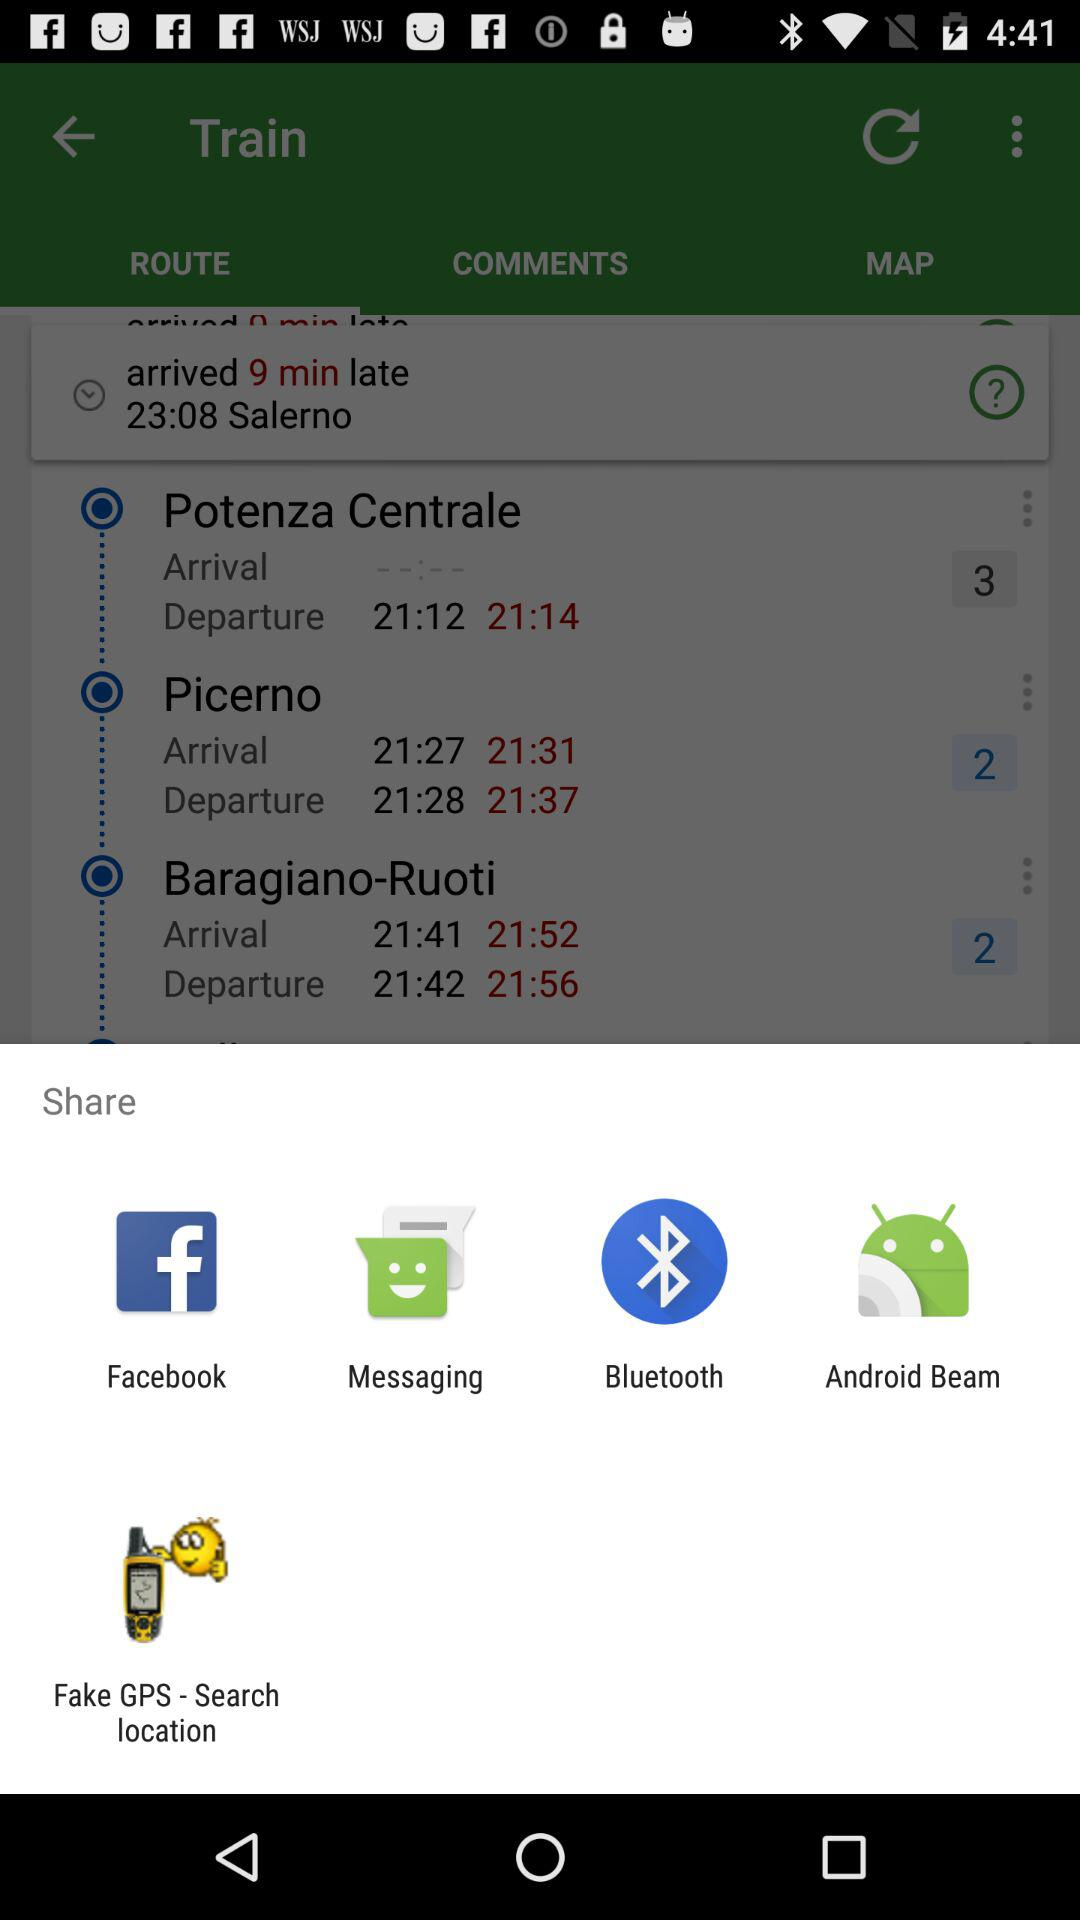What are the sharing options? The sharing options are "Facebook", "Messaging", "Bluetooth", "Android Beam" and "Fake GPS - Search location". 